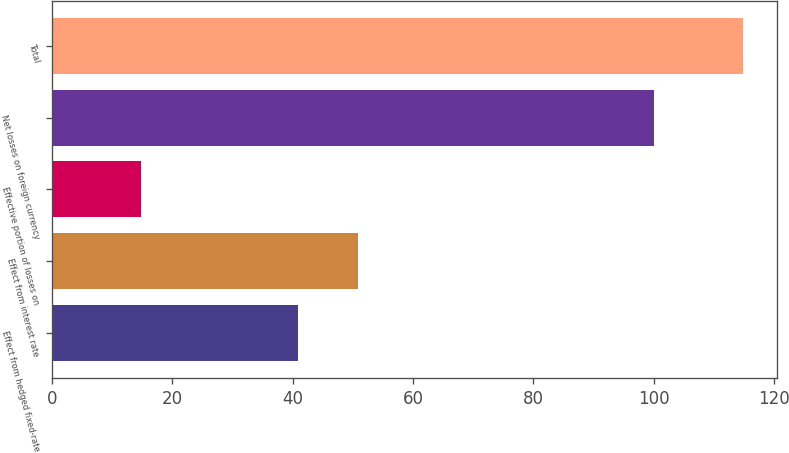Convert chart. <chart><loc_0><loc_0><loc_500><loc_500><bar_chart><fcel>Effect from hedged fixed-rate<fcel>Effect from interest rate<fcel>Effective portion of losses on<fcel>Net losses on foreign currency<fcel>Total<nl><fcel>40.9<fcel>50.9<fcel>14.8<fcel>100<fcel>114.8<nl></chart> 